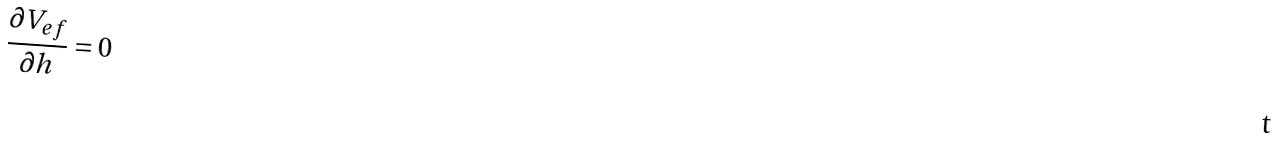Convert formula to latex. <formula><loc_0><loc_0><loc_500><loc_500>\frac { \partial V _ { e f } } { \partial h } = 0</formula> 